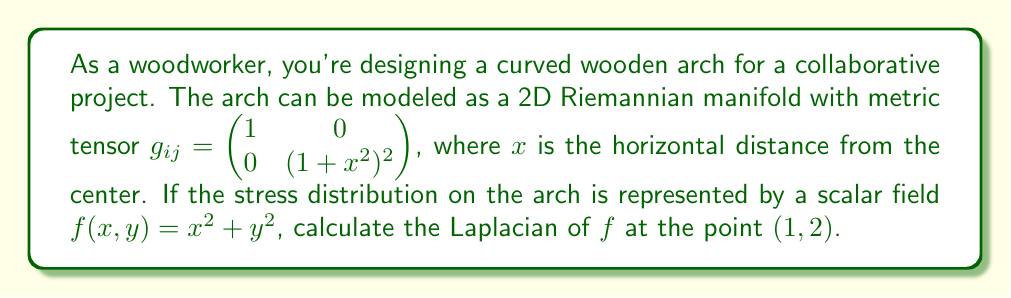Show me your answer to this math problem. To solve this problem, we'll follow these steps:

1) The Laplacian on a Riemannian manifold is given by:

   $$\Delta f = \frac{1}{\sqrt{|g|}} \partial_i (\sqrt{|g|} g^{ij} \partial_j f)$$

   where $g$ is the determinant of the metric tensor, and $g^{ij}$ is the inverse of the metric tensor.

2) First, let's calculate the determinant and inverse of the metric tensor:

   $|g| = 1 \cdot (1+x^2)^2 = (1+x^2)^2$

   $g^{ij} = \begin{pmatrix} 1 & 0 \\ 0 & \frac{1}{(1+x^2)^2} \end{pmatrix}$

3) Now, let's calculate the partial derivatives of $f$:

   $\partial_x f = 2x$
   $\partial_y f = 2y$

4) Next, we calculate $\sqrt{|g|} g^{ij} \partial_j f$:

   For $i=1$ (x-component): $(1+x^2) \cdot 1 \cdot 2x = 2x(1+x^2)$
   For $i=2$ (y-component): $(1+x^2) \cdot \frac{1}{(1+x^2)^2} \cdot 2y = \frac{2y}{1+x^2}$

5) Now we take the derivative of these components with respect to $x$ and $y$ respectively:

   $\partial_x [2x(1+x^2)] = 2(1+x^2) + 4x^2 = 2+6x^2$
   $\partial_y [\frac{2y}{1+x^2}] = \frac{2}{1+x^2}$

6) Finally, we sum these terms and divide by $\sqrt{|g|}$:

   $$\Delta f = \frac{1}{1+x^2} [(2+6x^2) + \frac{2}{1+x^2}]$$

7) At the point (1,2), $x=1$, so:

   $$\Delta f = \frac{1}{2} [(2+6) + \frac{2}{2}] = \frac{1}{2} [8 + 1] = \frac{9}{2} = 4.5$$
Answer: The Laplacian of $f$ at the point $(1,2)$ is $\frac{9}{2}$ or $4.5$. 